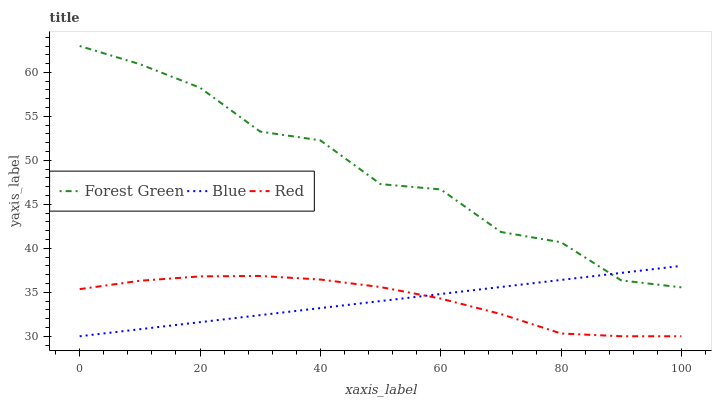Does Blue have the minimum area under the curve?
Answer yes or no. Yes. Does Forest Green have the maximum area under the curve?
Answer yes or no. Yes. Does Red have the minimum area under the curve?
Answer yes or no. No. Does Red have the maximum area under the curve?
Answer yes or no. No. Is Blue the smoothest?
Answer yes or no. Yes. Is Forest Green the roughest?
Answer yes or no. Yes. Is Red the smoothest?
Answer yes or no. No. Is Red the roughest?
Answer yes or no. No. Does Forest Green have the lowest value?
Answer yes or no. No. Does Forest Green have the highest value?
Answer yes or no. Yes. Does Red have the highest value?
Answer yes or no. No. Is Red less than Forest Green?
Answer yes or no. Yes. Is Forest Green greater than Red?
Answer yes or no. Yes. Does Red intersect Forest Green?
Answer yes or no. No. 